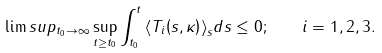Convert formula to latex. <formula><loc_0><loc_0><loc_500><loc_500>\lim s u p _ { t _ { 0 } \rightarrow \infty } \sup _ { t \geq t _ { 0 } } \int _ { t _ { 0 } } ^ { t } { \left \langle T _ { i } { \left ( s , \kappa \right ) } \right \rangle } _ { s } d s \leq 0 ; \quad i = 1 , 2 , 3 .</formula> 